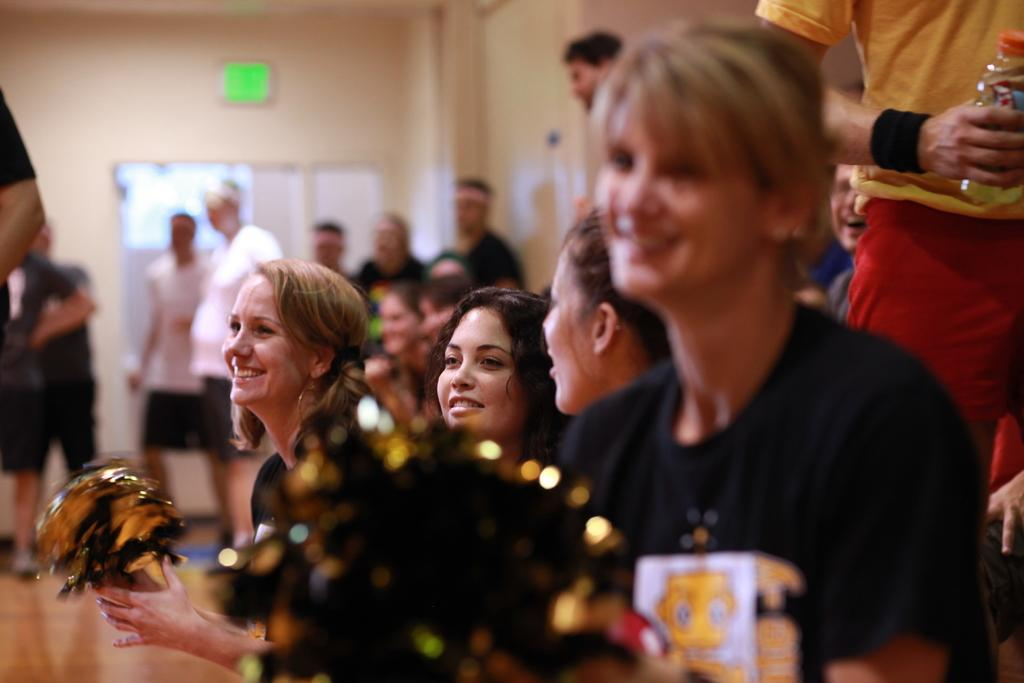How many people are in the image? There are people in the image, but the exact number is not specified. What are some people doing in the image? Some people are holding objects in the image. What can be seen in the background of the image? There is a wall in the background of the image. What is attached to the wall? There are boards on the wall. Can you tell me how many dolls are floating in the river in the image? There is no river or dolls present in the image. 